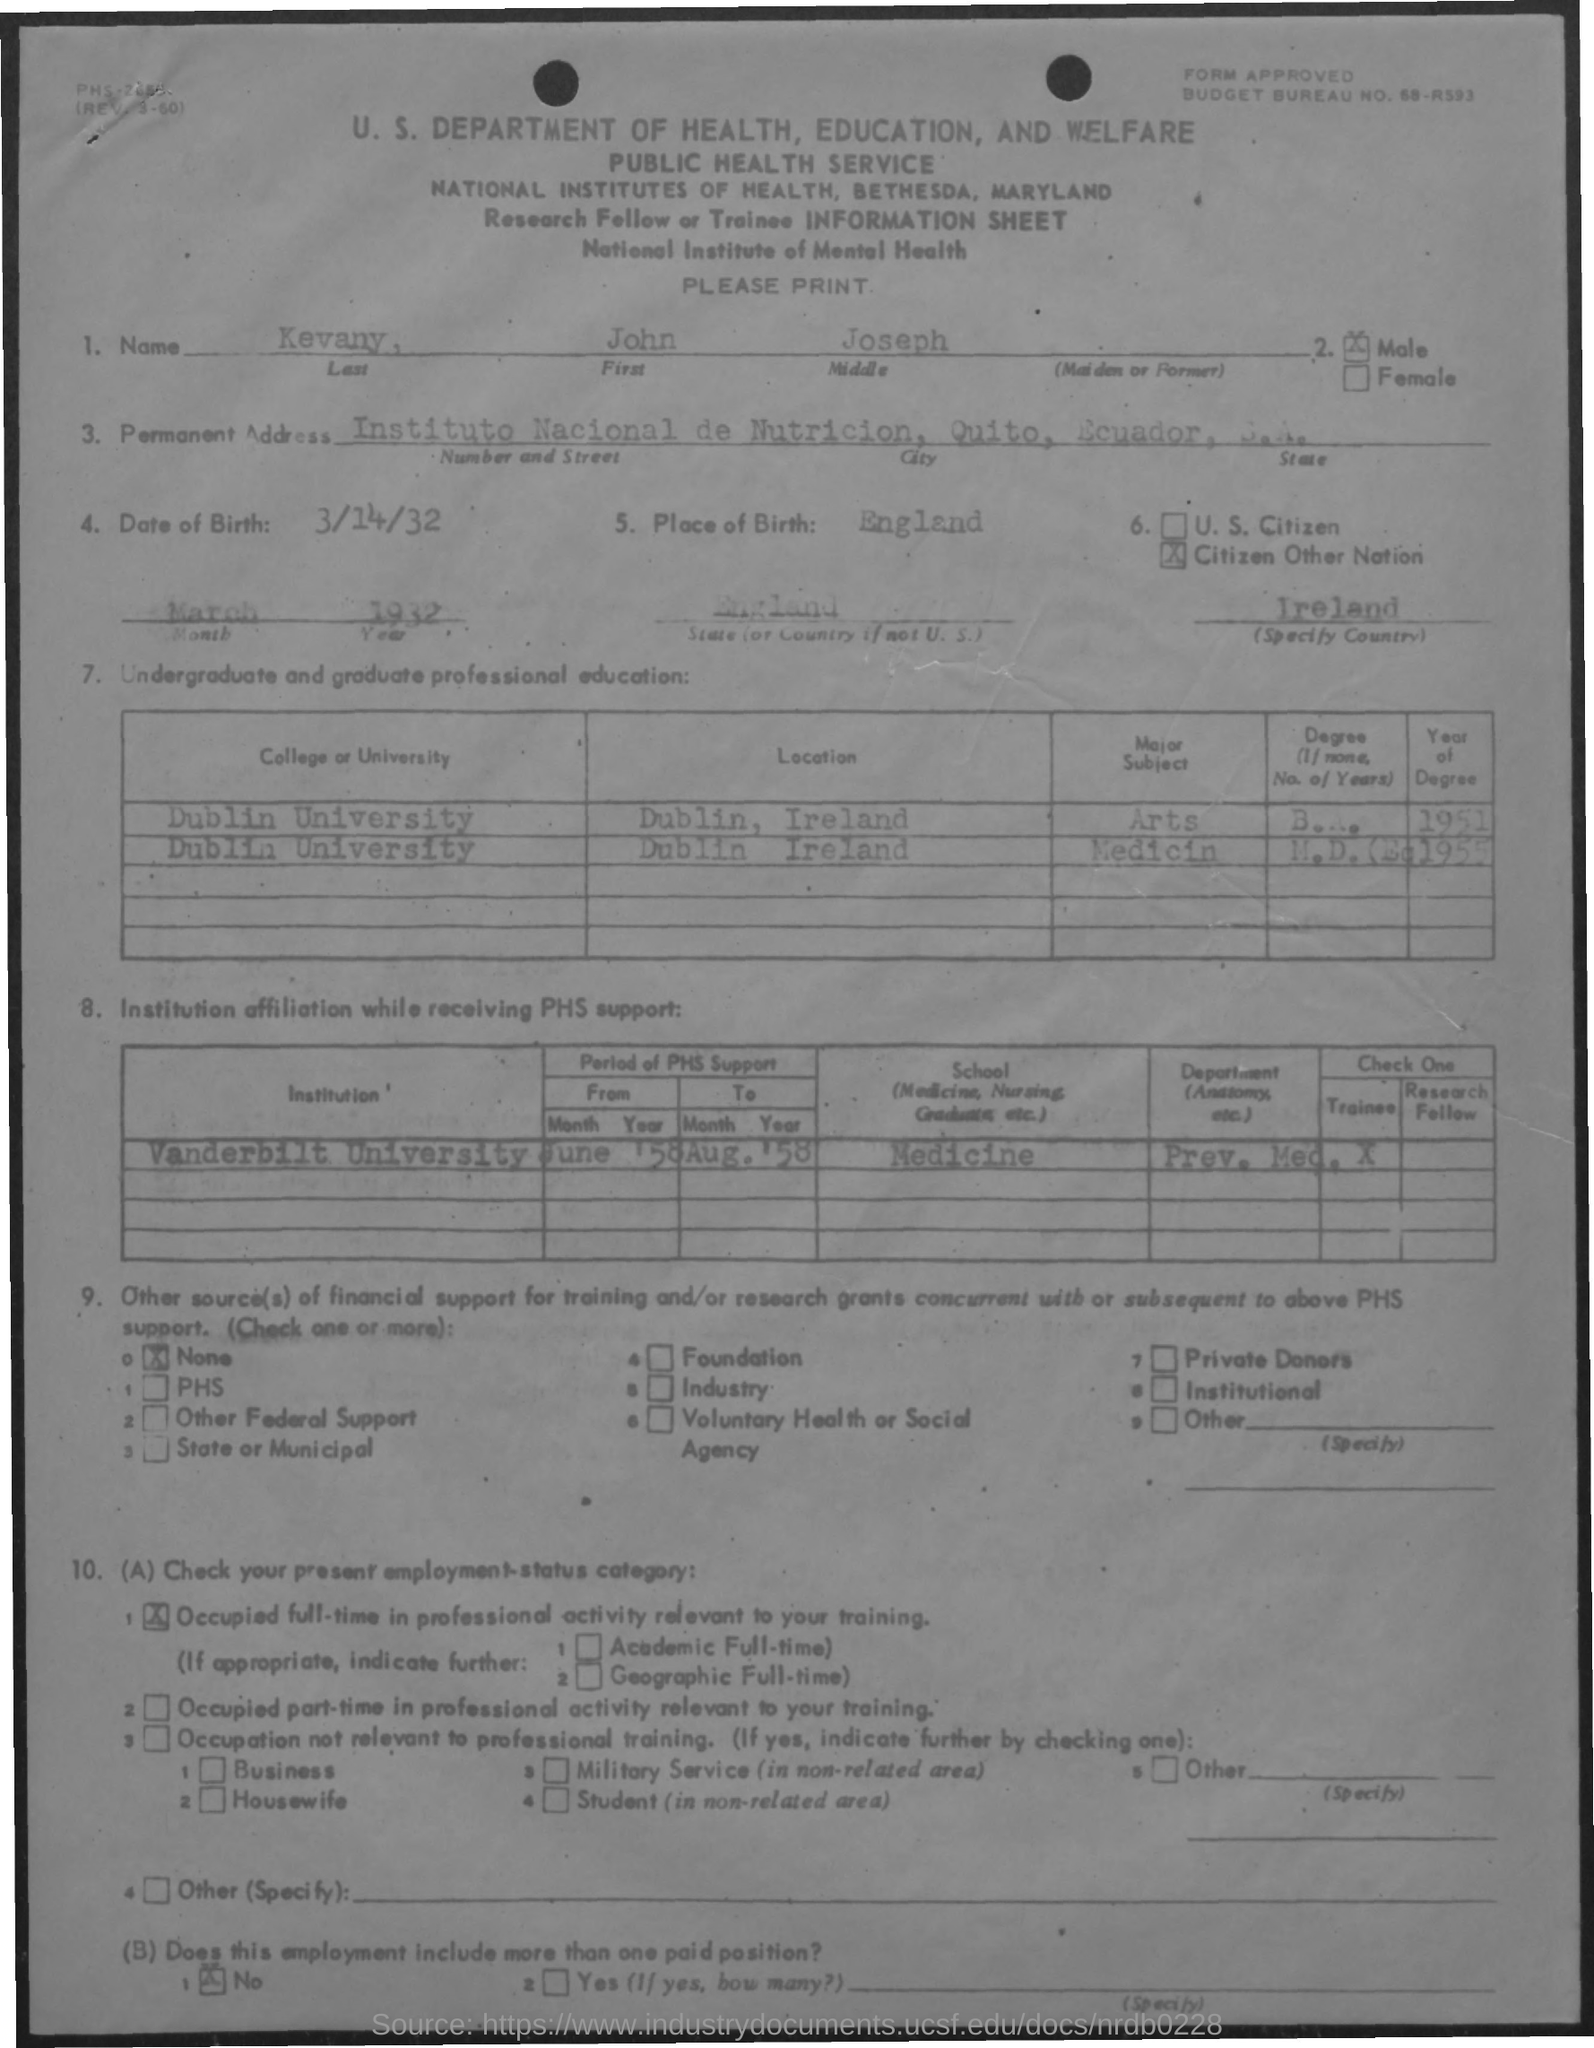What is the first name mentioned in the document?
Provide a short and direct response. John. What is the date of birth?
Ensure brevity in your answer.  3/14/32. What is the place of birth?
Offer a terse response. ENGLAND. 